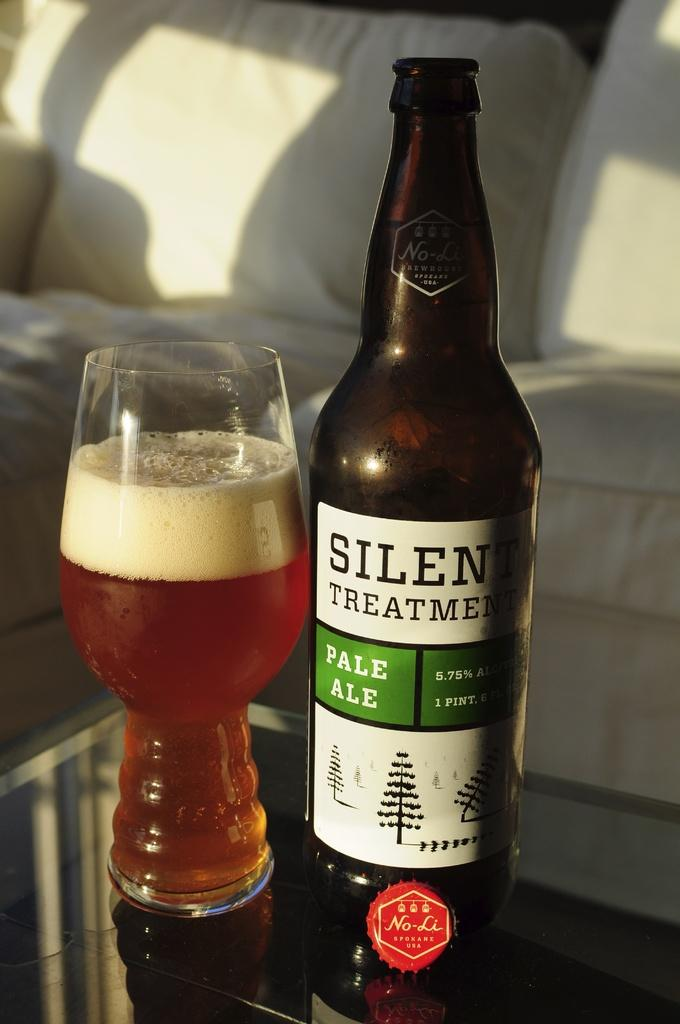Provide a one-sentence caption for the provided image. a silent treatment pale ale and a glass with it poured out. 